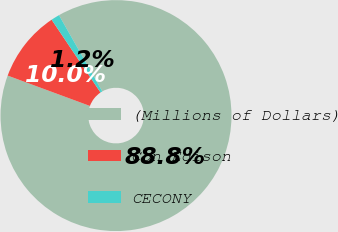Convert chart to OTSL. <chart><loc_0><loc_0><loc_500><loc_500><pie_chart><fcel>(Millions of Dollars)<fcel>Con Edison<fcel>CECONY<nl><fcel>88.85%<fcel>9.96%<fcel>1.19%<nl></chart> 